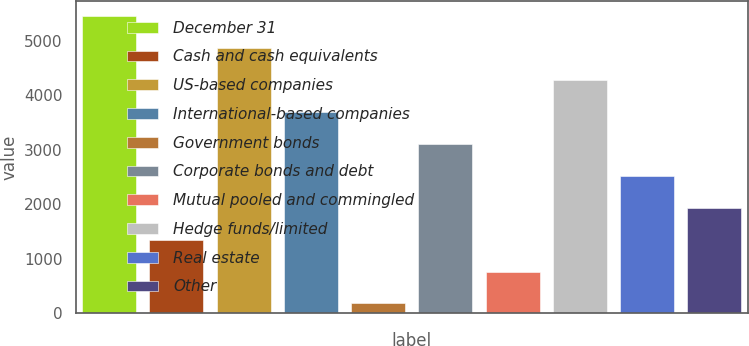<chart> <loc_0><loc_0><loc_500><loc_500><bar_chart><fcel>December 31<fcel>Cash and cash equivalents<fcel>US-based companies<fcel>International-based companies<fcel>Government bonds<fcel>Corporate bonds and debt<fcel>Mutual pooled and commingled<fcel>Hedge funds/limited<fcel>Real estate<fcel>Other<nl><fcel>5443.5<fcel>1352<fcel>4859<fcel>3690<fcel>183<fcel>3105.5<fcel>767.5<fcel>4274.5<fcel>2521<fcel>1936.5<nl></chart> 